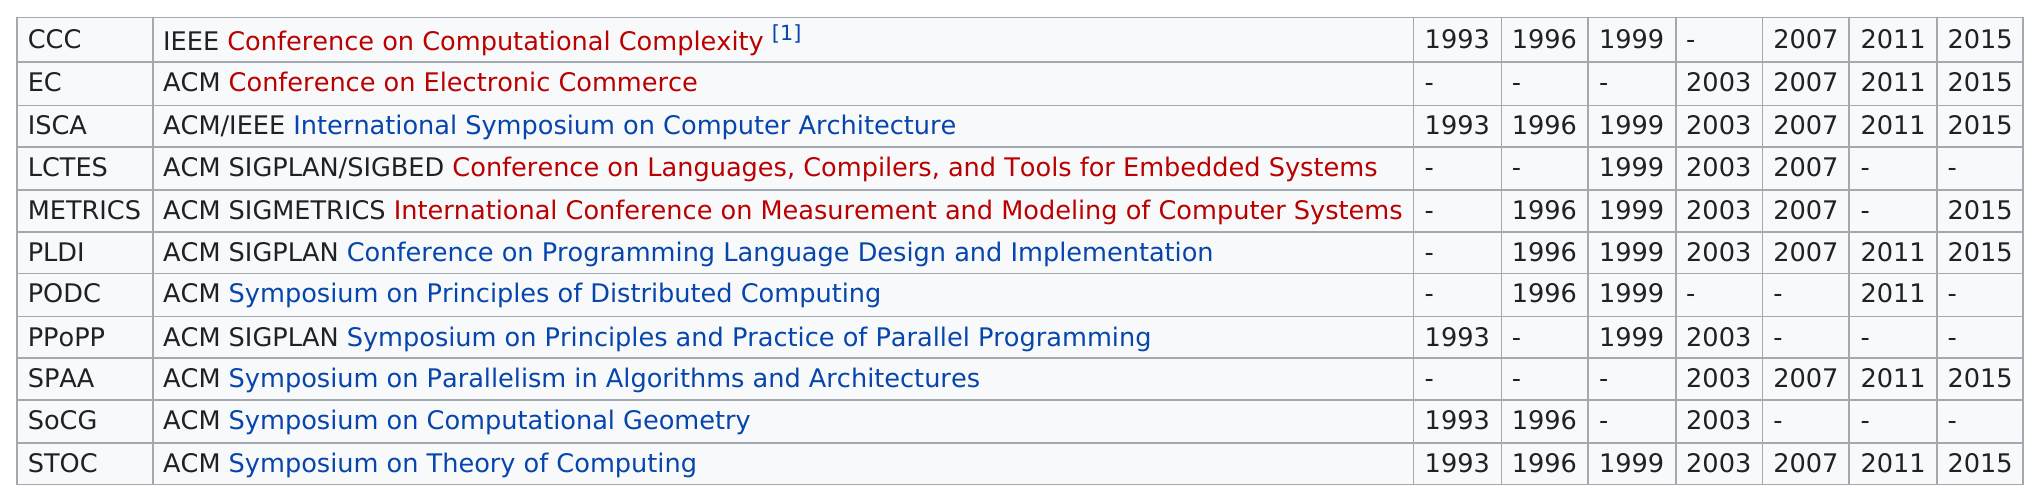Indicate a few pertinent items in this graphic. LCTES was active for a total of 8 years. The ACM Conference on Electronic Commerce was not a part of FCRC in the years 1993, 1996, and 1999. The symposium on principles and practice of parallel programming was held in 2003. The ISCA has attended 7 consecutive FRCs. The PPOpp has been a part of a total of 3 FDCRs. 